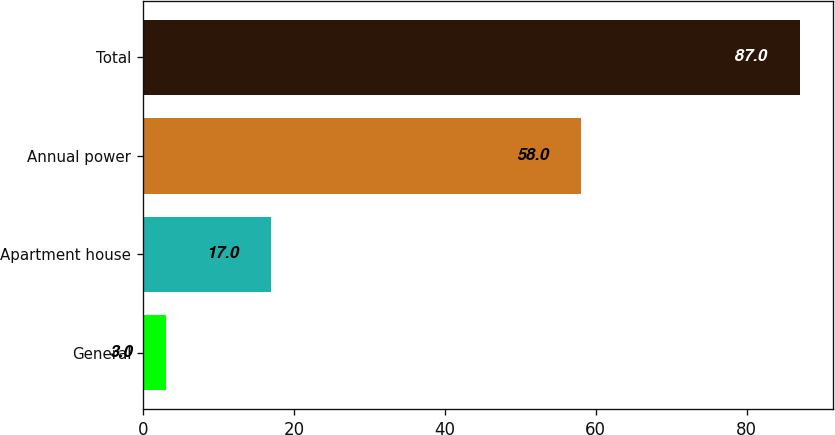<chart> <loc_0><loc_0><loc_500><loc_500><bar_chart><fcel>General<fcel>Apartment house<fcel>Annual power<fcel>Total<nl><fcel>3<fcel>17<fcel>58<fcel>87<nl></chart> 